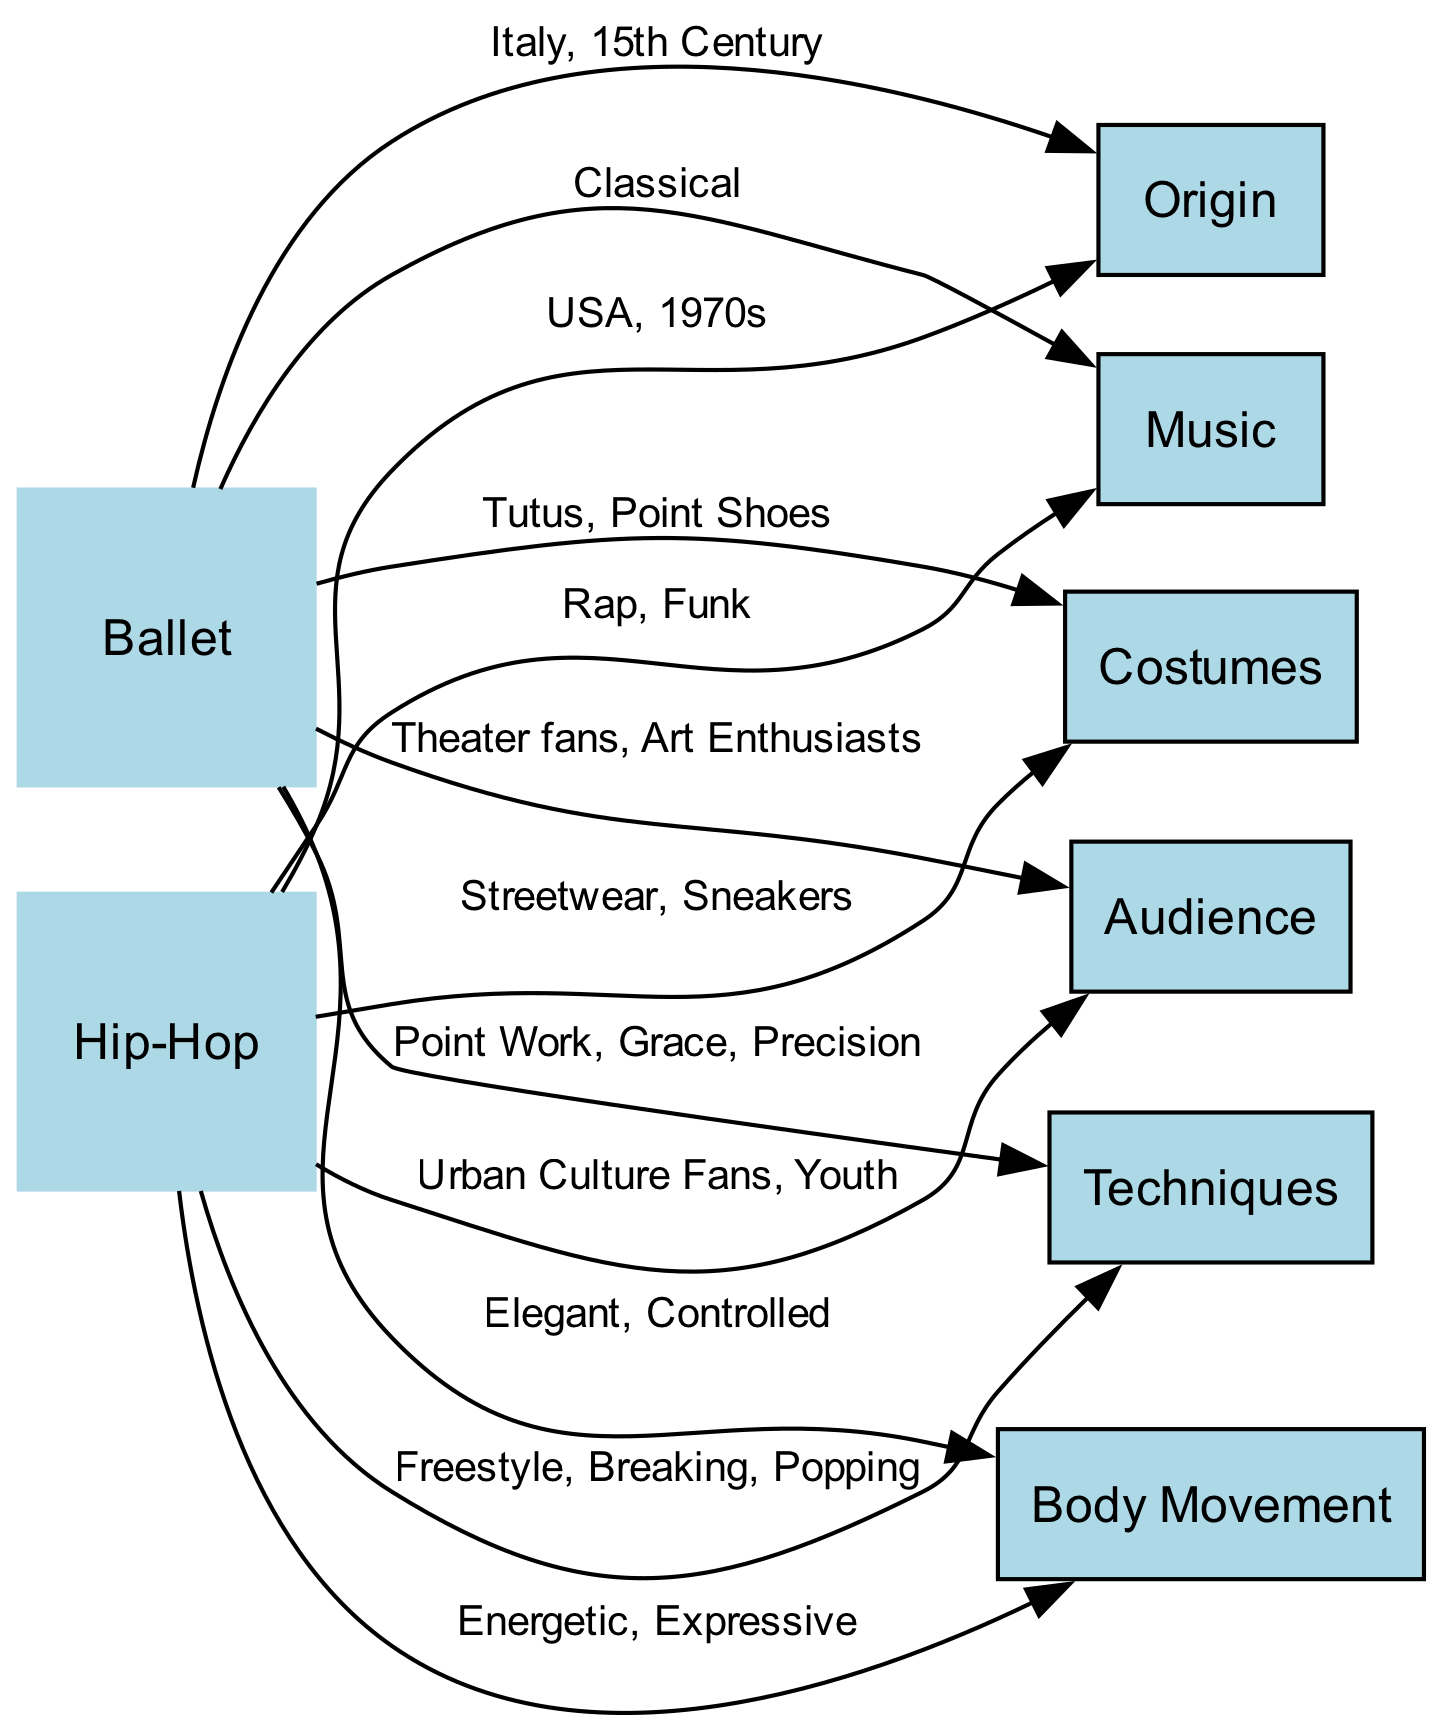What is the origin of Ballet? The diagram specifies that Ballet originated in Italy during the 15th Century, indicated by the edge connecting the "Ballet" node to the "Origin" node with this labeled relationship.
Answer: Italy, 15th Century What is the music associated with Hip-Hop? The diagram shows that the music associated with Hip-Hop is labeled as "Rap, Funk," connected through an edge from the "Hip-Hop" node to the "Music" node.
Answer: Rap, Funk How many nodes are there in the diagram? Counting the nodes listed shows a total of eight distinct nodes: Ballet, Hip-Hop, Origin, Techniques, Music, Costumes, Audience, and Body Movement.
Answer: 8 What techniques are unique to Ballet? The diagram shows Ballet techniques as "Point Work, Grace, Precision," connected through an edge from the "Ballet" node to the "Techniques" node.
Answer: Point Work, Grace, Precision What type of audience typically attends Ballet performances? According to the diagram, Ballet performances are attended by "Theater fans, Art Enthusiasts," indicated by the edge connecting "Ballet" to "Audience."
Answer: Theater fans, Art Enthusiasts Which dance style is characterized by energetic and expressive body movement? Analyzing the edges from the "Body Movement" node, it specifies that Hip-Hop features "Energetic, Expressive" body movements, connected to the "Hip-Hop" node.
Answer: Hip-Hop What costumes are associated with Hip-Hop? The edge from the "Hip-Hop" node to the "Costumes" node indicates that Hip-Hop costumes include "Streetwear, Sneakers."
Answer: Streetwear, Sneakers Which dance style originated in the 1970s? The edge in the diagram shows that Hip-Hop originated in the USA during the 1970s, while Ballet originated earlier. Thus, the answer reflects the style tied to this time period.
Answer: Hip-Hop 